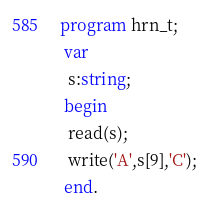Convert code to text. <code><loc_0><loc_0><loc_500><loc_500><_Pascal_>program hrn_t;
 var
  s:string;
 begin
  read(s);
  write('A',s[9],'C');
 end.</code> 